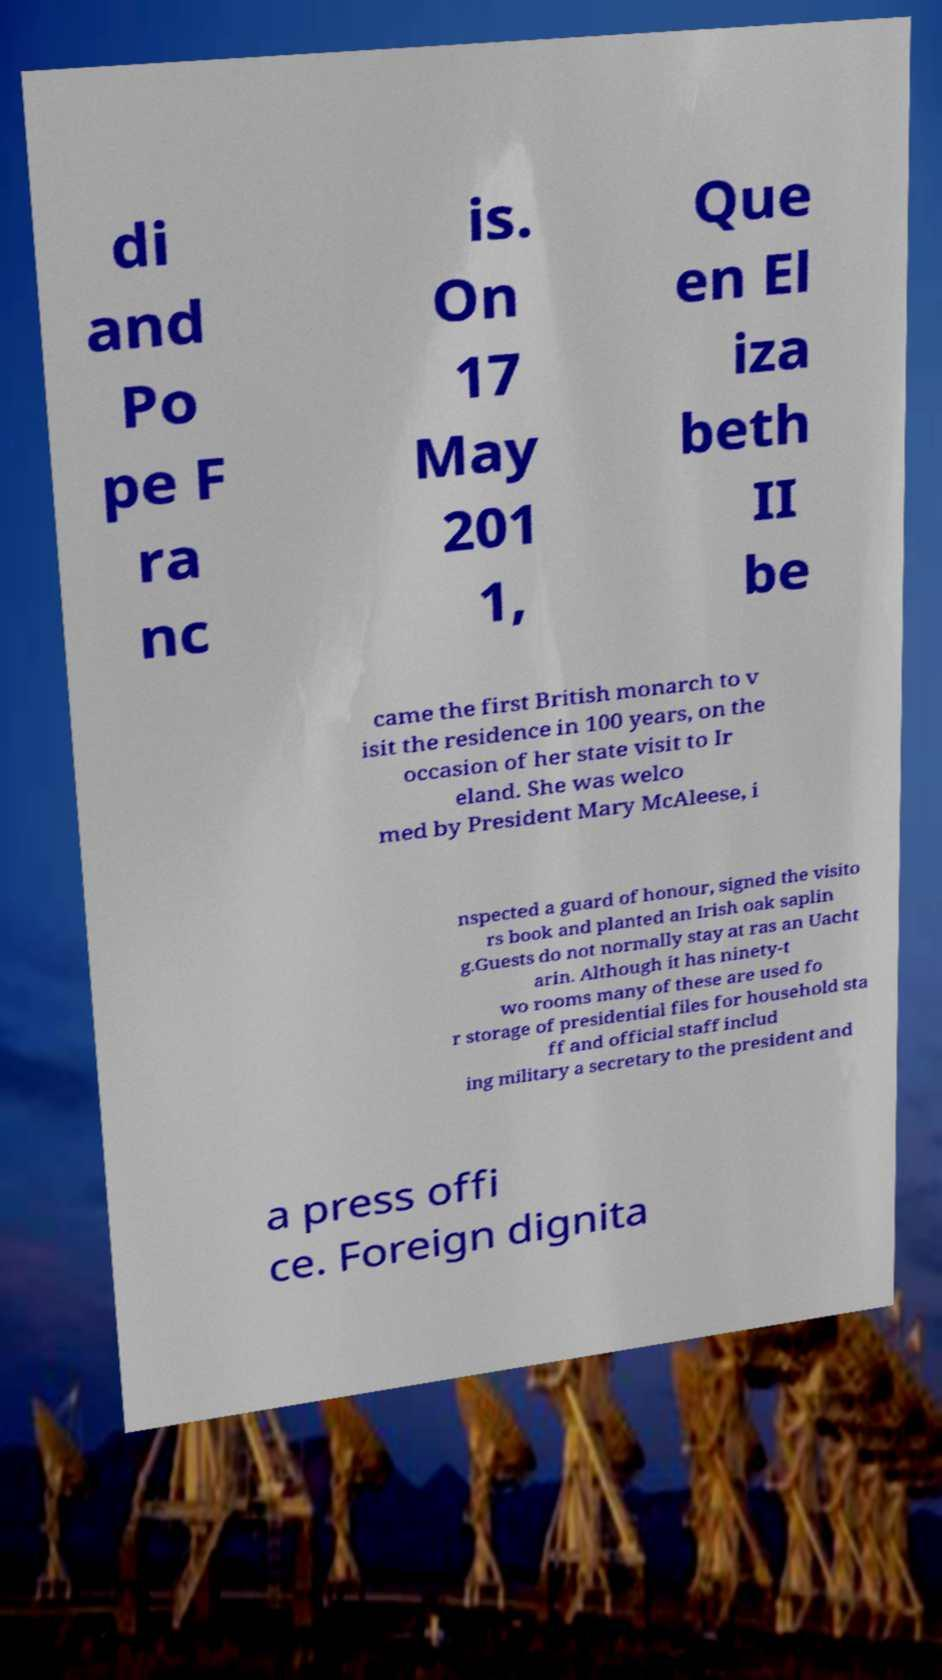Can you read and provide the text displayed in the image?This photo seems to have some interesting text. Can you extract and type it out for me? di and Po pe F ra nc is. On 17 May 201 1, Que en El iza beth II be came the first British monarch to v isit the residence in 100 years, on the occasion of her state visit to Ir eland. She was welco med by President Mary McAleese, i nspected a guard of honour, signed the visito rs book and planted an Irish oak saplin g.Guests do not normally stay at ras an Uacht arin. Although it has ninety-t wo rooms many of these are used fo r storage of presidential files for household sta ff and official staff includ ing military a secretary to the president and a press offi ce. Foreign dignita 